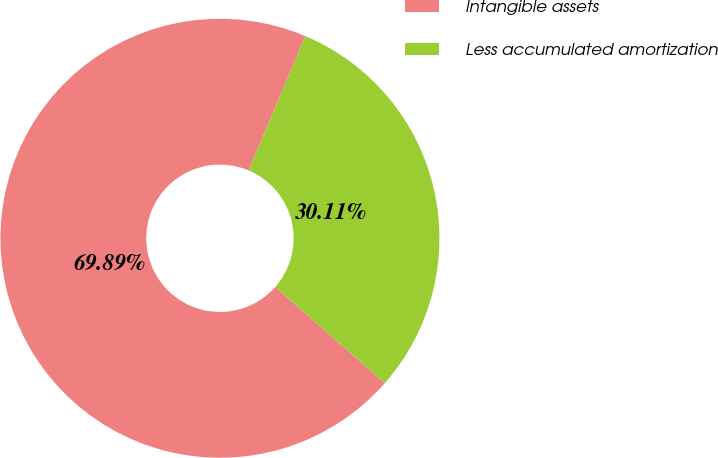Convert chart. <chart><loc_0><loc_0><loc_500><loc_500><pie_chart><fcel>Intangible assets<fcel>Less accumulated amortization<nl><fcel>69.89%<fcel>30.11%<nl></chart> 